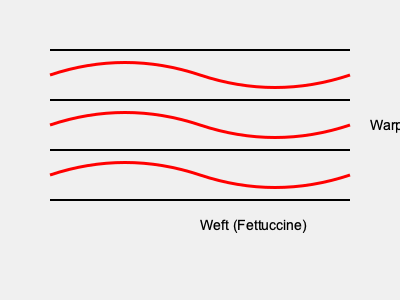In the pasta-inspired textile weave diagram above, which basic weave structure is represented, and how does it relate to the interlacement of warp and weft threads? To identify the weave structure and understand its relation to warp and weft threads, let's analyze the diagram step-by-step:

1. Observe the diagram: The horizontal black lines represent the warp threads, while the curvy red lines represent the weft threads (described as "Fettuccine" in this pasta-inspired design).

2. Analyze the interlacement pattern:
   - The weft (red lines) goes over one warp thread, then under one warp thread, alternating consistently.
   - This creates a simple, balanced pattern where warp and weft are equally visible on both sides of the fabric.

3. Identify the weave structure:
   - The one-over, one-under pattern is characteristic of the plain weave, also known as tabby weave.
   - Plain weave is the simplest and most common of all weave structures.

4. Understand the relationship between warp and weft:
   - In plain weave, each weft thread passes alternately over and under each warp thread.
   - This creates a strong, stable fabric with a balanced appearance on both sides.

5. Consider the pasta inspiration:
   - The use of fettuccine-like curves for the weft threads adds a creative, food-inspired element to the traditional weave diagram.
   - This aligns with the textile designer's approach of incorporating food-inspired patterns into fabric designs.

The plain weave structure represented here provides a simple yet versatile foundation for incorporating various design elements, making it an excellent choice for a food-inspired textile pattern.
Answer: Plain weave 